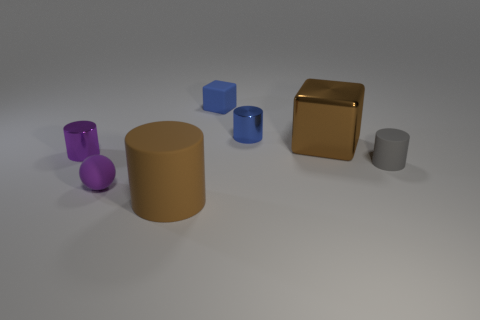There is a large object in front of the gray cylinder; what shape is it?
Make the answer very short. Cylinder. There is a blue metallic thing that is the same shape as the large matte object; what is its size?
Make the answer very short. Small. There is a small cylinder that is behind the cube to the right of the blue metal cylinder; what number of small purple rubber balls are in front of it?
Provide a succinct answer. 1. Are there the same number of small blue metallic things in front of the blue metallic object and big green blocks?
Give a very brief answer. Yes. What number of balls are tiny metallic objects or tiny blue rubber things?
Offer a terse response. 0. Is the color of the large rubber object the same as the small sphere?
Keep it short and to the point. No. Are there the same number of brown matte cylinders behind the small blue metal object and purple shiny objects that are in front of the small purple cylinder?
Keep it short and to the point. Yes. What is the color of the small rubber sphere?
Keep it short and to the point. Purple. How many objects are tiny purple objects that are in front of the tiny gray cylinder or brown matte cylinders?
Your response must be concise. 2. Is the size of the metal cylinder that is behind the small purple cylinder the same as the brown object that is on the left side of the large brown cube?
Offer a very short reply. No. 